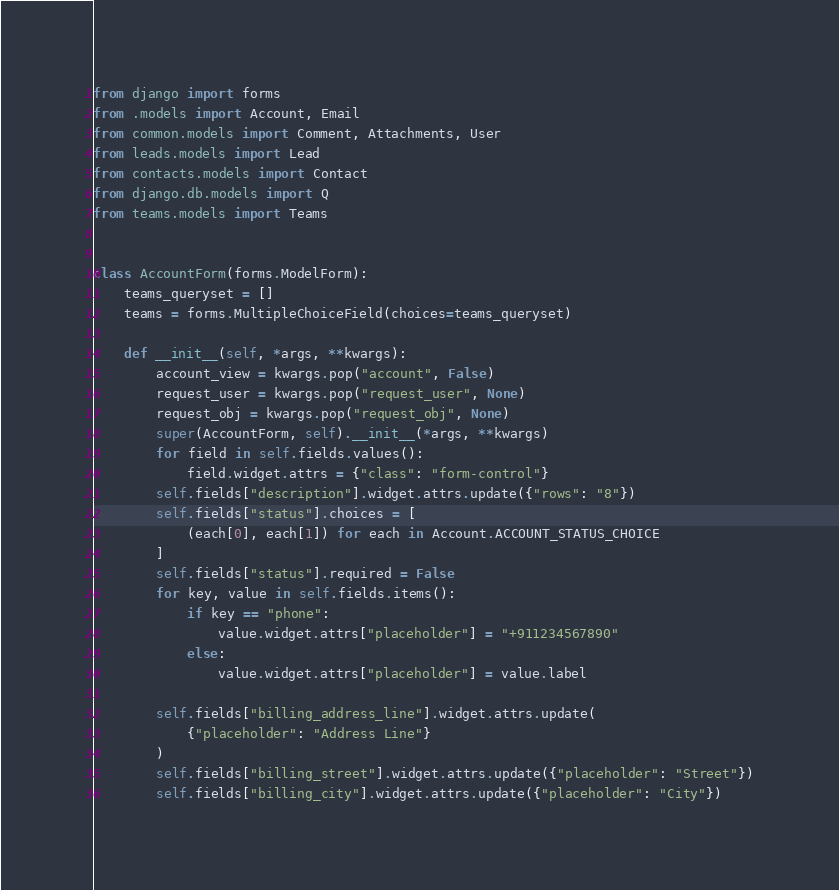<code> <loc_0><loc_0><loc_500><loc_500><_Python_>from django import forms
from .models import Account, Email
from common.models import Comment, Attachments, User
from leads.models import Lead
from contacts.models import Contact
from django.db.models import Q
from teams.models import Teams


class AccountForm(forms.ModelForm):
    teams_queryset = []
    teams = forms.MultipleChoiceField(choices=teams_queryset)

    def __init__(self, *args, **kwargs):
        account_view = kwargs.pop("account", False)
        request_user = kwargs.pop("request_user", None)
        request_obj = kwargs.pop("request_obj", None)
        super(AccountForm, self).__init__(*args, **kwargs)
        for field in self.fields.values():
            field.widget.attrs = {"class": "form-control"}
        self.fields["description"].widget.attrs.update({"rows": "8"})
        self.fields["status"].choices = [
            (each[0], each[1]) for each in Account.ACCOUNT_STATUS_CHOICE
        ]
        self.fields["status"].required = False
        for key, value in self.fields.items():
            if key == "phone":
                value.widget.attrs["placeholder"] = "+911234567890"
            else:
                value.widget.attrs["placeholder"] = value.label

        self.fields["billing_address_line"].widget.attrs.update(
            {"placeholder": "Address Line"}
        )
        self.fields["billing_street"].widget.attrs.update({"placeholder": "Street"})
        self.fields["billing_city"].widget.attrs.update({"placeholder": "City"})</code> 